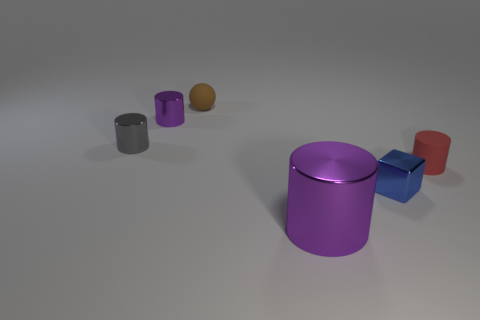Add 3 blocks. How many objects exist? 9 Subtract all cylinders. How many objects are left? 2 Subtract 1 brown spheres. How many objects are left? 5 Subtract all brown objects. Subtract all red cylinders. How many objects are left? 4 Add 2 brown rubber balls. How many brown rubber balls are left? 3 Add 2 large purple shiny cylinders. How many large purple shiny cylinders exist? 3 